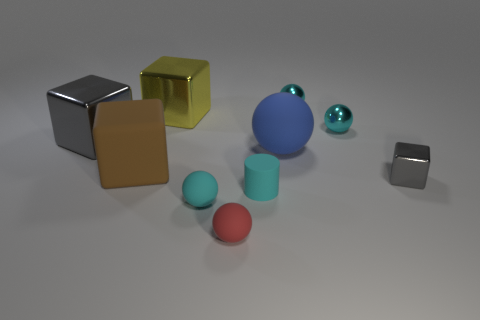What number of other things are there of the same material as the big blue sphere
Your answer should be very brief. 4. How big is the block that is both in front of the blue matte sphere and left of the small cyan rubber sphere?
Your answer should be compact. Large. What is the shape of the gray metallic thing behind the shiny cube that is on the right side of the tiny red rubber object?
Provide a succinct answer. Cube. Is there anything else that is the same shape as the red rubber object?
Offer a very short reply. Yes. Are there an equal number of small cyan spheres in front of the large brown rubber thing and big rubber blocks?
Provide a short and direct response. Yes. There is a small block; is it the same color as the big matte thing that is in front of the large sphere?
Your answer should be very brief. No. What color is the ball that is in front of the tiny gray metal block and behind the red ball?
Your response must be concise. Cyan. What number of yellow cubes are in front of the cyan thing left of the tiny cyan matte cylinder?
Make the answer very short. 0. Is there a blue thing of the same shape as the yellow object?
Provide a succinct answer. No. There is a gray metallic object behind the big matte sphere; does it have the same shape as the large matte thing that is on the left side of the rubber cylinder?
Ensure brevity in your answer.  Yes. 